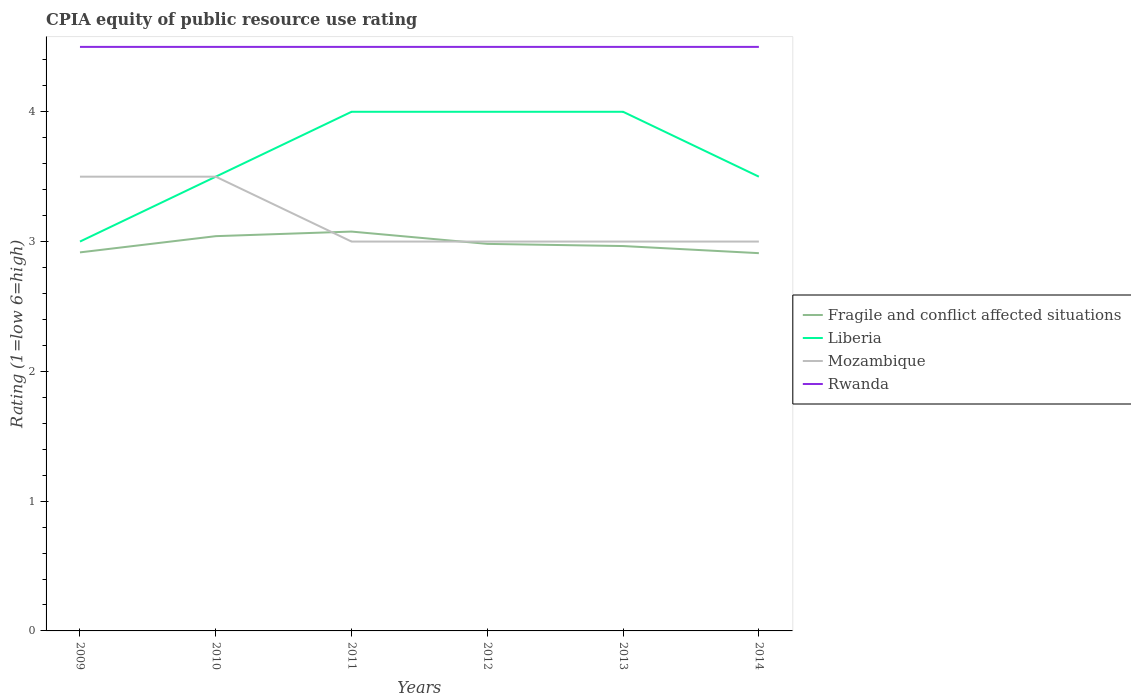Is the number of lines equal to the number of legend labels?
Keep it short and to the point. Yes. Across all years, what is the maximum CPIA rating in Rwanda?
Offer a very short reply. 4.5. In which year was the CPIA rating in Mozambique maximum?
Make the answer very short. 2011. How many years are there in the graph?
Make the answer very short. 6. What is the difference between two consecutive major ticks on the Y-axis?
Keep it short and to the point. 1. Does the graph contain grids?
Your response must be concise. No. How many legend labels are there?
Ensure brevity in your answer.  4. What is the title of the graph?
Make the answer very short. CPIA equity of public resource use rating. What is the Rating (1=low 6=high) in Fragile and conflict affected situations in 2009?
Offer a very short reply. 2.92. What is the Rating (1=low 6=high) in Liberia in 2009?
Make the answer very short. 3. What is the Rating (1=low 6=high) in Mozambique in 2009?
Give a very brief answer. 3.5. What is the Rating (1=low 6=high) in Fragile and conflict affected situations in 2010?
Give a very brief answer. 3.04. What is the Rating (1=low 6=high) in Mozambique in 2010?
Offer a very short reply. 3.5. What is the Rating (1=low 6=high) in Rwanda in 2010?
Make the answer very short. 4.5. What is the Rating (1=low 6=high) in Fragile and conflict affected situations in 2011?
Your answer should be very brief. 3.08. What is the Rating (1=low 6=high) in Liberia in 2011?
Ensure brevity in your answer.  4. What is the Rating (1=low 6=high) in Fragile and conflict affected situations in 2012?
Your answer should be very brief. 2.98. What is the Rating (1=low 6=high) in Liberia in 2012?
Keep it short and to the point. 4. What is the Rating (1=low 6=high) in Mozambique in 2012?
Keep it short and to the point. 3. What is the Rating (1=low 6=high) in Fragile and conflict affected situations in 2013?
Give a very brief answer. 2.97. What is the Rating (1=low 6=high) of Mozambique in 2013?
Provide a succinct answer. 3. What is the Rating (1=low 6=high) of Rwanda in 2013?
Ensure brevity in your answer.  4.5. What is the Rating (1=low 6=high) in Fragile and conflict affected situations in 2014?
Keep it short and to the point. 2.91. What is the Rating (1=low 6=high) of Liberia in 2014?
Your answer should be very brief. 3.5. What is the Rating (1=low 6=high) of Mozambique in 2014?
Provide a succinct answer. 3. What is the Rating (1=low 6=high) of Rwanda in 2014?
Give a very brief answer. 4.5. Across all years, what is the maximum Rating (1=low 6=high) of Fragile and conflict affected situations?
Ensure brevity in your answer.  3.08. Across all years, what is the minimum Rating (1=low 6=high) of Fragile and conflict affected situations?
Keep it short and to the point. 2.91. Across all years, what is the minimum Rating (1=low 6=high) in Liberia?
Make the answer very short. 3. What is the total Rating (1=low 6=high) of Fragile and conflict affected situations in the graph?
Your answer should be compact. 17.89. What is the total Rating (1=low 6=high) of Liberia in the graph?
Offer a very short reply. 22. What is the total Rating (1=low 6=high) in Mozambique in the graph?
Offer a very short reply. 19. What is the total Rating (1=low 6=high) in Rwanda in the graph?
Keep it short and to the point. 27. What is the difference between the Rating (1=low 6=high) of Fragile and conflict affected situations in 2009 and that in 2010?
Keep it short and to the point. -0.12. What is the difference between the Rating (1=low 6=high) of Rwanda in 2009 and that in 2010?
Ensure brevity in your answer.  0. What is the difference between the Rating (1=low 6=high) of Fragile and conflict affected situations in 2009 and that in 2011?
Ensure brevity in your answer.  -0.16. What is the difference between the Rating (1=low 6=high) of Liberia in 2009 and that in 2011?
Ensure brevity in your answer.  -1. What is the difference between the Rating (1=low 6=high) in Fragile and conflict affected situations in 2009 and that in 2012?
Keep it short and to the point. -0.07. What is the difference between the Rating (1=low 6=high) of Liberia in 2009 and that in 2012?
Your response must be concise. -1. What is the difference between the Rating (1=low 6=high) of Fragile and conflict affected situations in 2009 and that in 2013?
Offer a terse response. -0.05. What is the difference between the Rating (1=low 6=high) of Liberia in 2009 and that in 2013?
Provide a succinct answer. -1. What is the difference between the Rating (1=low 6=high) in Rwanda in 2009 and that in 2013?
Your answer should be very brief. 0. What is the difference between the Rating (1=low 6=high) in Fragile and conflict affected situations in 2009 and that in 2014?
Your answer should be compact. 0.01. What is the difference between the Rating (1=low 6=high) of Mozambique in 2009 and that in 2014?
Ensure brevity in your answer.  0.5. What is the difference between the Rating (1=low 6=high) in Fragile and conflict affected situations in 2010 and that in 2011?
Keep it short and to the point. -0.04. What is the difference between the Rating (1=low 6=high) in Liberia in 2010 and that in 2011?
Make the answer very short. -0.5. What is the difference between the Rating (1=low 6=high) of Rwanda in 2010 and that in 2011?
Offer a very short reply. 0. What is the difference between the Rating (1=low 6=high) of Fragile and conflict affected situations in 2010 and that in 2012?
Make the answer very short. 0.06. What is the difference between the Rating (1=low 6=high) in Liberia in 2010 and that in 2012?
Offer a terse response. -0.5. What is the difference between the Rating (1=low 6=high) in Rwanda in 2010 and that in 2012?
Give a very brief answer. 0. What is the difference between the Rating (1=low 6=high) of Fragile and conflict affected situations in 2010 and that in 2013?
Your response must be concise. 0.08. What is the difference between the Rating (1=low 6=high) in Mozambique in 2010 and that in 2013?
Keep it short and to the point. 0.5. What is the difference between the Rating (1=low 6=high) of Rwanda in 2010 and that in 2013?
Give a very brief answer. 0. What is the difference between the Rating (1=low 6=high) in Fragile and conflict affected situations in 2010 and that in 2014?
Offer a terse response. 0.13. What is the difference between the Rating (1=low 6=high) of Rwanda in 2010 and that in 2014?
Provide a succinct answer. 0. What is the difference between the Rating (1=low 6=high) of Fragile and conflict affected situations in 2011 and that in 2012?
Ensure brevity in your answer.  0.09. What is the difference between the Rating (1=low 6=high) of Liberia in 2011 and that in 2012?
Ensure brevity in your answer.  0. What is the difference between the Rating (1=low 6=high) of Fragile and conflict affected situations in 2011 and that in 2013?
Give a very brief answer. 0.11. What is the difference between the Rating (1=low 6=high) in Mozambique in 2011 and that in 2013?
Ensure brevity in your answer.  0. What is the difference between the Rating (1=low 6=high) in Fragile and conflict affected situations in 2011 and that in 2014?
Keep it short and to the point. 0.17. What is the difference between the Rating (1=low 6=high) in Mozambique in 2011 and that in 2014?
Ensure brevity in your answer.  0. What is the difference between the Rating (1=low 6=high) in Rwanda in 2011 and that in 2014?
Provide a short and direct response. 0. What is the difference between the Rating (1=low 6=high) of Fragile and conflict affected situations in 2012 and that in 2013?
Provide a short and direct response. 0.02. What is the difference between the Rating (1=low 6=high) in Liberia in 2012 and that in 2013?
Your answer should be very brief. 0. What is the difference between the Rating (1=low 6=high) in Rwanda in 2012 and that in 2013?
Offer a terse response. 0. What is the difference between the Rating (1=low 6=high) of Fragile and conflict affected situations in 2012 and that in 2014?
Provide a short and direct response. 0.07. What is the difference between the Rating (1=low 6=high) in Rwanda in 2012 and that in 2014?
Your answer should be compact. 0. What is the difference between the Rating (1=low 6=high) of Fragile and conflict affected situations in 2013 and that in 2014?
Offer a terse response. 0.05. What is the difference between the Rating (1=low 6=high) of Fragile and conflict affected situations in 2009 and the Rating (1=low 6=high) of Liberia in 2010?
Ensure brevity in your answer.  -0.58. What is the difference between the Rating (1=low 6=high) of Fragile and conflict affected situations in 2009 and the Rating (1=low 6=high) of Mozambique in 2010?
Ensure brevity in your answer.  -0.58. What is the difference between the Rating (1=low 6=high) in Fragile and conflict affected situations in 2009 and the Rating (1=low 6=high) in Rwanda in 2010?
Provide a short and direct response. -1.58. What is the difference between the Rating (1=low 6=high) of Liberia in 2009 and the Rating (1=low 6=high) of Rwanda in 2010?
Ensure brevity in your answer.  -1.5. What is the difference between the Rating (1=low 6=high) in Fragile and conflict affected situations in 2009 and the Rating (1=low 6=high) in Liberia in 2011?
Provide a succinct answer. -1.08. What is the difference between the Rating (1=low 6=high) of Fragile and conflict affected situations in 2009 and the Rating (1=low 6=high) of Mozambique in 2011?
Keep it short and to the point. -0.08. What is the difference between the Rating (1=low 6=high) of Fragile and conflict affected situations in 2009 and the Rating (1=low 6=high) of Rwanda in 2011?
Ensure brevity in your answer.  -1.58. What is the difference between the Rating (1=low 6=high) in Liberia in 2009 and the Rating (1=low 6=high) in Mozambique in 2011?
Make the answer very short. 0. What is the difference between the Rating (1=low 6=high) of Fragile and conflict affected situations in 2009 and the Rating (1=low 6=high) of Liberia in 2012?
Your answer should be very brief. -1.08. What is the difference between the Rating (1=low 6=high) of Fragile and conflict affected situations in 2009 and the Rating (1=low 6=high) of Mozambique in 2012?
Provide a succinct answer. -0.08. What is the difference between the Rating (1=low 6=high) of Fragile and conflict affected situations in 2009 and the Rating (1=low 6=high) of Rwanda in 2012?
Keep it short and to the point. -1.58. What is the difference between the Rating (1=low 6=high) of Liberia in 2009 and the Rating (1=low 6=high) of Mozambique in 2012?
Your answer should be compact. 0. What is the difference between the Rating (1=low 6=high) of Liberia in 2009 and the Rating (1=low 6=high) of Rwanda in 2012?
Provide a short and direct response. -1.5. What is the difference between the Rating (1=low 6=high) of Fragile and conflict affected situations in 2009 and the Rating (1=low 6=high) of Liberia in 2013?
Your answer should be compact. -1.08. What is the difference between the Rating (1=low 6=high) of Fragile and conflict affected situations in 2009 and the Rating (1=low 6=high) of Mozambique in 2013?
Your answer should be very brief. -0.08. What is the difference between the Rating (1=low 6=high) of Fragile and conflict affected situations in 2009 and the Rating (1=low 6=high) of Rwanda in 2013?
Your response must be concise. -1.58. What is the difference between the Rating (1=low 6=high) of Fragile and conflict affected situations in 2009 and the Rating (1=low 6=high) of Liberia in 2014?
Ensure brevity in your answer.  -0.58. What is the difference between the Rating (1=low 6=high) of Fragile and conflict affected situations in 2009 and the Rating (1=low 6=high) of Mozambique in 2014?
Offer a terse response. -0.08. What is the difference between the Rating (1=low 6=high) in Fragile and conflict affected situations in 2009 and the Rating (1=low 6=high) in Rwanda in 2014?
Your answer should be very brief. -1.58. What is the difference between the Rating (1=low 6=high) of Liberia in 2009 and the Rating (1=low 6=high) of Rwanda in 2014?
Offer a very short reply. -1.5. What is the difference between the Rating (1=low 6=high) in Fragile and conflict affected situations in 2010 and the Rating (1=low 6=high) in Liberia in 2011?
Provide a short and direct response. -0.96. What is the difference between the Rating (1=low 6=high) in Fragile and conflict affected situations in 2010 and the Rating (1=low 6=high) in Mozambique in 2011?
Provide a short and direct response. 0.04. What is the difference between the Rating (1=low 6=high) in Fragile and conflict affected situations in 2010 and the Rating (1=low 6=high) in Rwanda in 2011?
Ensure brevity in your answer.  -1.46. What is the difference between the Rating (1=low 6=high) in Liberia in 2010 and the Rating (1=low 6=high) in Mozambique in 2011?
Ensure brevity in your answer.  0.5. What is the difference between the Rating (1=low 6=high) in Fragile and conflict affected situations in 2010 and the Rating (1=low 6=high) in Liberia in 2012?
Keep it short and to the point. -0.96. What is the difference between the Rating (1=low 6=high) of Fragile and conflict affected situations in 2010 and the Rating (1=low 6=high) of Mozambique in 2012?
Your answer should be compact. 0.04. What is the difference between the Rating (1=low 6=high) in Fragile and conflict affected situations in 2010 and the Rating (1=low 6=high) in Rwanda in 2012?
Provide a succinct answer. -1.46. What is the difference between the Rating (1=low 6=high) of Liberia in 2010 and the Rating (1=low 6=high) of Mozambique in 2012?
Your answer should be compact. 0.5. What is the difference between the Rating (1=low 6=high) of Mozambique in 2010 and the Rating (1=low 6=high) of Rwanda in 2012?
Provide a succinct answer. -1. What is the difference between the Rating (1=low 6=high) in Fragile and conflict affected situations in 2010 and the Rating (1=low 6=high) in Liberia in 2013?
Offer a terse response. -0.96. What is the difference between the Rating (1=low 6=high) of Fragile and conflict affected situations in 2010 and the Rating (1=low 6=high) of Mozambique in 2013?
Provide a succinct answer. 0.04. What is the difference between the Rating (1=low 6=high) of Fragile and conflict affected situations in 2010 and the Rating (1=low 6=high) of Rwanda in 2013?
Ensure brevity in your answer.  -1.46. What is the difference between the Rating (1=low 6=high) of Fragile and conflict affected situations in 2010 and the Rating (1=low 6=high) of Liberia in 2014?
Offer a very short reply. -0.46. What is the difference between the Rating (1=low 6=high) of Fragile and conflict affected situations in 2010 and the Rating (1=low 6=high) of Mozambique in 2014?
Give a very brief answer. 0.04. What is the difference between the Rating (1=low 6=high) in Fragile and conflict affected situations in 2010 and the Rating (1=low 6=high) in Rwanda in 2014?
Your response must be concise. -1.46. What is the difference between the Rating (1=low 6=high) in Liberia in 2010 and the Rating (1=low 6=high) in Mozambique in 2014?
Make the answer very short. 0.5. What is the difference between the Rating (1=low 6=high) of Liberia in 2010 and the Rating (1=low 6=high) of Rwanda in 2014?
Your response must be concise. -1. What is the difference between the Rating (1=low 6=high) in Mozambique in 2010 and the Rating (1=low 6=high) in Rwanda in 2014?
Your response must be concise. -1. What is the difference between the Rating (1=low 6=high) of Fragile and conflict affected situations in 2011 and the Rating (1=low 6=high) of Liberia in 2012?
Offer a terse response. -0.92. What is the difference between the Rating (1=low 6=high) in Fragile and conflict affected situations in 2011 and the Rating (1=low 6=high) in Mozambique in 2012?
Your answer should be compact. 0.08. What is the difference between the Rating (1=low 6=high) in Fragile and conflict affected situations in 2011 and the Rating (1=low 6=high) in Rwanda in 2012?
Provide a succinct answer. -1.42. What is the difference between the Rating (1=low 6=high) of Mozambique in 2011 and the Rating (1=low 6=high) of Rwanda in 2012?
Your answer should be very brief. -1.5. What is the difference between the Rating (1=low 6=high) of Fragile and conflict affected situations in 2011 and the Rating (1=low 6=high) of Liberia in 2013?
Offer a terse response. -0.92. What is the difference between the Rating (1=low 6=high) in Fragile and conflict affected situations in 2011 and the Rating (1=low 6=high) in Mozambique in 2013?
Ensure brevity in your answer.  0.08. What is the difference between the Rating (1=low 6=high) in Fragile and conflict affected situations in 2011 and the Rating (1=low 6=high) in Rwanda in 2013?
Provide a short and direct response. -1.42. What is the difference between the Rating (1=low 6=high) in Mozambique in 2011 and the Rating (1=low 6=high) in Rwanda in 2013?
Offer a very short reply. -1.5. What is the difference between the Rating (1=low 6=high) in Fragile and conflict affected situations in 2011 and the Rating (1=low 6=high) in Liberia in 2014?
Provide a short and direct response. -0.42. What is the difference between the Rating (1=low 6=high) of Fragile and conflict affected situations in 2011 and the Rating (1=low 6=high) of Mozambique in 2014?
Your response must be concise. 0.08. What is the difference between the Rating (1=low 6=high) of Fragile and conflict affected situations in 2011 and the Rating (1=low 6=high) of Rwanda in 2014?
Provide a short and direct response. -1.42. What is the difference between the Rating (1=low 6=high) in Fragile and conflict affected situations in 2012 and the Rating (1=low 6=high) in Liberia in 2013?
Offer a very short reply. -1.02. What is the difference between the Rating (1=low 6=high) of Fragile and conflict affected situations in 2012 and the Rating (1=low 6=high) of Mozambique in 2013?
Make the answer very short. -0.02. What is the difference between the Rating (1=low 6=high) of Fragile and conflict affected situations in 2012 and the Rating (1=low 6=high) of Rwanda in 2013?
Your answer should be very brief. -1.52. What is the difference between the Rating (1=low 6=high) in Fragile and conflict affected situations in 2012 and the Rating (1=low 6=high) in Liberia in 2014?
Ensure brevity in your answer.  -0.52. What is the difference between the Rating (1=low 6=high) in Fragile and conflict affected situations in 2012 and the Rating (1=low 6=high) in Mozambique in 2014?
Ensure brevity in your answer.  -0.02. What is the difference between the Rating (1=low 6=high) in Fragile and conflict affected situations in 2012 and the Rating (1=low 6=high) in Rwanda in 2014?
Offer a very short reply. -1.52. What is the difference between the Rating (1=low 6=high) in Liberia in 2012 and the Rating (1=low 6=high) in Mozambique in 2014?
Give a very brief answer. 1. What is the difference between the Rating (1=low 6=high) of Liberia in 2012 and the Rating (1=low 6=high) of Rwanda in 2014?
Your answer should be very brief. -0.5. What is the difference between the Rating (1=low 6=high) of Mozambique in 2012 and the Rating (1=low 6=high) of Rwanda in 2014?
Provide a short and direct response. -1.5. What is the difference between the Rating (1=low 6=high) in Fragile and conflict affected situations in 2013 and the Rating (1=low 6=high) in Liberia in 2014?
Offer a terse response. -0.53. What is the difference between the Rating (1=low 6=high) in Fragile and conflict affected situations in 2013 and the Rating (1=low 6=high) in Mozambique in 2014?
Make the answer very short. -0.03. What is the difference between the Rating (1=low 6=high) of Fragile and conflict affected situations in 2013 and the Rating (1=low 6=high) of Rwanda in 2014?
Provide a short and direct response. -1.53. What is the difference between the Rating (1=low 6=high) in Liberia in 2013 and the Rating (1=low 6=high) in Rwanda in 2014?
Offer a very short reply. -0.5. What is the average Rating (1=low 6=high) in Fragile and conflict affected situations per year?
Give a very brief answer. 2.98. What is the average Rating (1=low 6=high) of Liberia per year?
Offer a very short reply. 3.67. What is the average Rating (1=low 6=high) in Mozambique per year?
Give a very brief answer. 3.17. What is the average Rating (1=low 6=high) of Rwanda per year?
Offer a terse response. 4.5. In the year 2009, what is the difference between the Rating (1=low 6=high) of Fragile and conflict affected situations and Rating (1=low 6=high) of Liberia?
Offer a very short reply. -0.08. In the year 2009, what is the difference between the Rating (1=low 6=high) in Fragile and conflict affected situations and Rating (1=low 6=high) in Mozambique?
Offer a very short reply. -0.58. In the year 2009, what is the difference between the Rating (1=low 6=high) in Fragile and conflict affected situations and Rating (1=low 6=high) in Rwanda?
Make the answer very short. -1.58. In the year 2010, what is the difference between the Rating (1=low 6=high) in Fragile and conflict affected situations and Rating (1=low 6=high) in Liberia?
Offer a terse response. -0.46. In the year 2010, what is the difference between the Rating (1=low 6=high) of Fragile and conflict affected situations and Rating (1=low 6=high) of Mozambique?
Your response must be concise. -0.46. In the year 2010, what is the difference between the Rating (1=low 6=high) of Fragile and conflict affected situations and Rating (1=low 6=high) of Rwanda?
Your response must be concise. -1.46. In the year 2010, what is the difference between the Rating (1=low 6=high) in Liberia and Rating (1=low 6=high) in Mozambique?
Make the answer very short. 0. In the year 2010, what is the difference between the Rating (1=low 6=high) of Liberia and Rating (1=low 6=high) of Rwanda?
Provide a short and direct response. -1. In the year 2010, what is the difference between the Rating (1=low 6=high) in Mozambique and Rating (1=low 6=high) in Rwanda?
Provide a short and direct response. -1. In the year 2011, what is the difference between the Rating (1=low 6=high) of Fragile and conflict affected situations and Rating (1=low 6=high) of Liberia?
Give a very brief answer. -0.92. In the year 2011, what is the difference between the Rating (1=low 6=high) in Fragile and conflict affected situations and Rating (1=low 6=high) in Mozambique?
Provide a succinct answer. 0.08. In the year 2011, what is the difference between the Rating (1=low 6=high) of Fragile and conflict affected situations and Rating (1=low 6=high) of Rwanda?
Your response must be concise. -1.42. In the year 2012, what is the difference between the Rating (1=low 6=high) of Fragile and conflict affected situations and Rating (1=low 6=high) of Liberia?
Your answer should be very brief. -1.02. In the year 2012, what is the difference between the Rating (1=low 6=high) of Fragile and conflict affected situations and Rating (1=low 6=high) of Mozambique?
Offer a very short reply. -0.02. In the year 2012, what is the difference between the Rating (1=low 6=high) in Fragile and conflict affected situations and Rating (1=low 6=high) in Rwanda?
Keep it short and to the point. -1.52. In the year 2012, what is the difference between the Rating (1=low 6=high) in Liberia and Rating (1=low 6=high) in Rwanda?
Offer a terse response. -0.5. In the year 2013, what is the difference between the Rating (1=low 6=high) of Fragile and conflict affected situations and Rating (1=low 6=high) of Liberia?
Make the answer very short. -1.03. In the year 2013, what is the difference between the Rating (1=low 6=high) of Fragile and conflict affected situations and Rating (1=low 6=high) of Mozambique?
Provide a succinct answer. -0.03. In the year 2013, what is the difference between the Rating (1=low 6=high) in Fragile and conflict affected situations and Rating (1=low 6=high) in Rwanda?
Provide a short and direct response. -1.53. In the year 2013, what is the difference between the Rating (1=low 6=high) in Liberia and Rating (1=low 6=high) in Rwanda?
Make the answer very short. -0.5. In the year 2013, what is the difference between the Rating (1=low 6=high) in Mozambique and Rating (1=low 6=high) in Rwanda?
Offer a very short reply. -1.5. In the year 2014, what is the difference between the Rating (1=low 6=high) of Fragile and conflict affected situations and Rating (1=low 6=high) of Liberia?
Ensure brevity in your answer.  -0.59. In the year 2014, what is the difference between the Rating (1=low 6=high) in Fragile and conflict affected situations and Rating (1=low 6=high) in Mozambique?
Your answer should be very brief. -0.09. In the year 2014, what is the difference between the Rating (1=low 6=high) of Fragile and conflict affected situations and Rating (1=low 6=high) of Rwanda?
Your answer should be very brief. -1.59. In the year 2014, what is the difference between the Rating (1=low 6=high) in Liberia and Rating (1=low 6=high) in Mozambique?
Keep it short and to the point. 0.5. In the year 2014, what is the difference between the Rating (1=low 6=high) in Liberia and Rating (1=low 6=high) in Rwanda?
Provide a succinct answer. -1. In the year 2014, what is the difference between the Rating (1=low 6=high) of Mozambique and Rating (1=low 6=high) of Rwanda?
Your response must be concise. -1.5. What is the ratio of the Rating (1=low 6=high) of Fragile and conflict affected situations in 2009 to that in 2010?
Offer a terse response. 0.96. What is the ratio of the Rating (1=low 6=high) of Mozambique in 2009 to that in 2010?
Provide a short and direct response. 1. What is the ratio of the Rating (1=low 6=high) of Rwanda in 2009 to that in 2010?
Offer a very short reply. 1. What is the ratio of the Rating (1=low 6=high) of Fragile and conflict affected situations in 2009 to that in 2011?
Provide a short and direct response. 0.95. What is the ratio of the Rating (1=low 6=high) of Liberia in 2009 to that in 2011?
Your answer should be compact. 0.75. What is the ratio of the Rating (1=low 6=high) in Mozambique in 2009 to that in 2011?
Offer a terse response. 1.17. What is the ratio of the Rating (1=low 6=high) of Rwanda in 2009 to that in 2011?
Give a very brief answer. 1. What is the ratio of the Rating (1=low 6=high) in Fragile and conflict affected situations in 2009 to that in 2012?
Provide a succinct answer. 0.98. What is the ratio of the Rating (1=low 6=high) in Liberia in 2009 to that in 2012?
Offer a terse response. 0.75. What is the ratio of the Rating (1=low 6=high) in Rwanda in 2009 to that in 2012?
Provide a short and direct response. 1. What is the ratio of the Rating (1=low 6=high) in Fragile and conflict affected situations in 2009 to that in 2013?
Your answer should be very brief. 0.98. What is the ratio of the Rating (1=low 6=high) in Rwanda in 2009 to that in 2013?
Give a very brief answer. 1. What is the ratio of the Rating (1=low 6=high) in Liberia in 2009 to that in 2014?
Give a very brief answer. 0.86. What is the ratio of the Rating (1=low 6=high) of Fragile and conflict affected situations in 2010 to that in 2011?
Offer a very short reply. 0.99. What is the ratio of the Rating (1=low 6=high) in Fragile and conflict affected situations in 2010 to that in 2012?
Make the answer very short. 1.02. What is the ratio of the Rating (1=low 6=high) in Rwanda in 2010 to that in 2012?
Offer a terse response. 1. What is the ratio of the Rating (1=low 6=high) of Fragile and conflict affected situations in 2010 to that in 2013?
Give a very brief answer. 1.03. What is the ratio of the Rating (1=low 6=high) in Liberia in 2010 to that in 2013?
Offer a very short reply. 0.88. What is the ratio of the Rating (1=low 6=high) of Fragile and conflict affected situations in 2010 to that in 2014?
Provide a succinct answer. 1.04. What is the ratio of the Rating (1=low 6=high) in Liberia in 2010 to that in 2014?
Provide a succinct answer. 1. What is the ratio of the Rating (1=low 6=high) in Mozambique in 2010 to that in 2014?
Your answer should be compact. 1.17. What is the ratio of the Rating (1=low 6=high) of Rwanda in 2010 to that in 2014?
Give a very brief answer. 1. What is the ratio of the Rating (1=low 6=high) in Fragile and conflict affected situations in 2011 to that in 2012?
Provide a succinct answer. 1.03. What is the ratio of the Rating (1=low 6=high) in Fragile and conflict affected situations in 2011 to that in 2013?
Your answer should be very brief. 1.04. What is the ratio of the Rating (1=low 6=high) of Mozambique in 2011 to that in 2013?
Your answer should be very brief. 1. What is the ratio of the Rating (1=low 6=high) of Rwanda in 2011 to that in 2013?
Make the answer very short. 1. What is the ratio of the Rating (1=low 6=high) of Fragile and conflict affected situations in 2011 to that in 2014?
Offer a very short reply. 1.06. What is the ratio of the Rating (1=low 6=high) of Liberia in 2011 to that in 2014?
Provide a succinct answer. 1.14. What is the ratio of the Rating (1=low 6=high) in Mozambique in 2011 to that in 2014?
Give a very brief answer. 1. What is the ratio of the Rating (1=low 6=high) of Fragile and conflict affected situations in 2012 to that in 2013?
Provide a short and direct response. 1.01. What is the ratio of the Rating (1=low 6=high) in Liberia in 2012 to that in 2013?
Offer a very short reply. 1. What is the ratio of the Rating (1=low 6=high) of Mozambique in 2012 to that in 2013?
Give a very brief answer. 1. What is the ratio of the Rating (1=low 6=high) of Rwanda in 2012 to that in 2013?
Provide a succinct answer. 1. What is the ratio of the Rating (1=low 6=high) of Fragile and conflict affected situations in 2012 to that in 2014?
Ensure brevity in your answer.  1.02. What is the ratio of the Rating (1=low 6=high) of Liberia in 2012 to that in 2014?
Give a very brief answer. 1.14. What is the ratio of the Rating (1=low 6=high) of Fragile and conflict affected situations in 2013 to that in 2014?
Provide a short and direct response. 1.02. What is the ratio of the Rating (1=low 6=high) in Rwanda in 2013 to that in 2014?
Provide a short and direct response. 1. What is the difference between the highest and the second highest Rating (1=low 6=high) of Fragile and conflict affected situations?
Provide a short and direct response. 0.04. What is the difference between the highest and the second highest Rating (1=low 6=high) in Liberia?
Provide a short and direct response. 0. What is the difference between the highest and the second highest Rating (1=low 6=high) of Mozambique?
Provide a short and direct response. 0. What is the difference between the highest and the lowest Rating (1=low 6=high) in Fragile and conflict affected situations?
Provide a short and direct response. 0.17. What is the difference between the highest and the lowest Rating (1=low 6=high) in Liberia?
Provide a succinct answer. 1. 